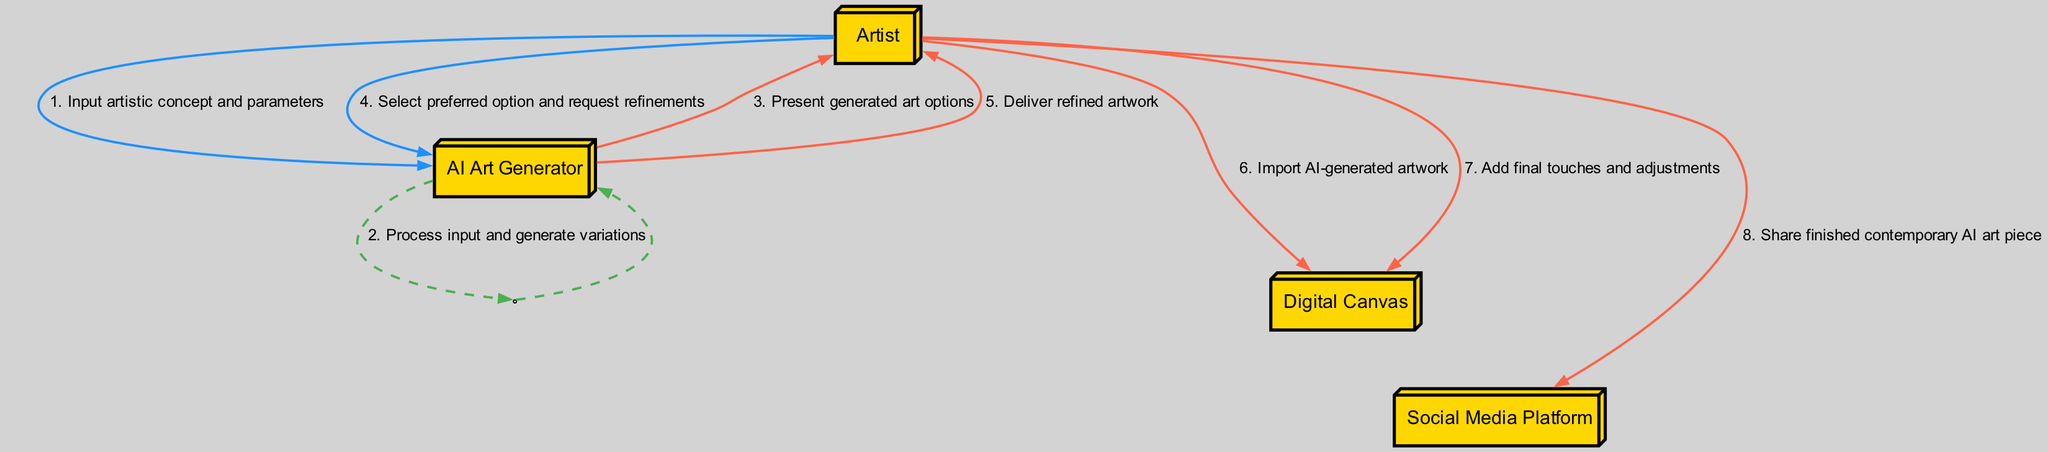What is the first message from the Artist? The first message in the diagram from the Artist is "Input artistic concept and parameters," which initiates the interaction with the AI Art Generator.
Answer: Input artistic concept and parameters How many actors are involved in this workflow? The diagram shows four actors: Artist, AI Art Generator, Digital Canvas, and Social Media Platform. Therefore, the total number of actors is four.
Answer: 4 Which actor generates variations? The actor that processes the input and generates variations is the AI Art Generator, as indicated by the flow of messages.
Answer: AI Art Generator What message does the Artist send when selecting artwork? The Artist sends the message "Select preferred option and request refinements" to the AI Art Generator when choosing their preferred artwork.
Answer: Select preferred option and request refinements How many times does the AI Art Generator communicate with the Artist? The AI Art Generator communicates with the Artist three times: after processing the input to present art options, when delivering the refined artwork, and during the selection process.
Answer: 3 What is the final action taken by the Artist in this workflow? The final action taken by the Artist is sharing the finished contemporary AI art piece on the Social Media Platform, marking the completion of the workflow.
Answer: Share finished contemporary AI art piece Which messages involve the Digital Canvas? The messages involving the Digital Canvas are "Import AI-generated artwork" and "Add final touches and adjustments," which indicate the Artist's actions regarding the artwork.
Answer: Import AI-generated artwork; Add final touches and adjustments What type of diagram is being represented? The diagram represents a Sequence diagram, which illustrates the order of messages exchanged between the actors in the workflow of generating art with AI.
Answer: Sequence diagram What happens after the AI Art Generator delivers the refined artwork? After the AI Art Generator delivers the refined artwork, the Artist imports it into the Digital Canvas for further editing, establishing a flow from the delivery to the next step in the process.
Answer: The Artist imports it into the Digital Canvas 